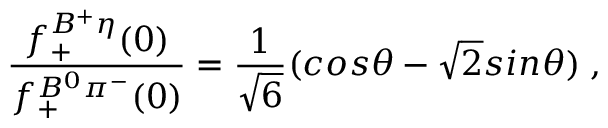Convert formula to latex. <formula><loc_0><loc_0><loc_500><loc_500>\frac { f _ { + } ^ { B ^ { + } \eta } ( 0 ) } { f _ { + } ^ { B ^ { 0 } \pi ^ { - } } ( 0 ) } = \frac { 1 } { \sqrt { 6 } } ( \cos \theta - { \sqrt { 2 } } \sin \theta ) \, ,</formula> 